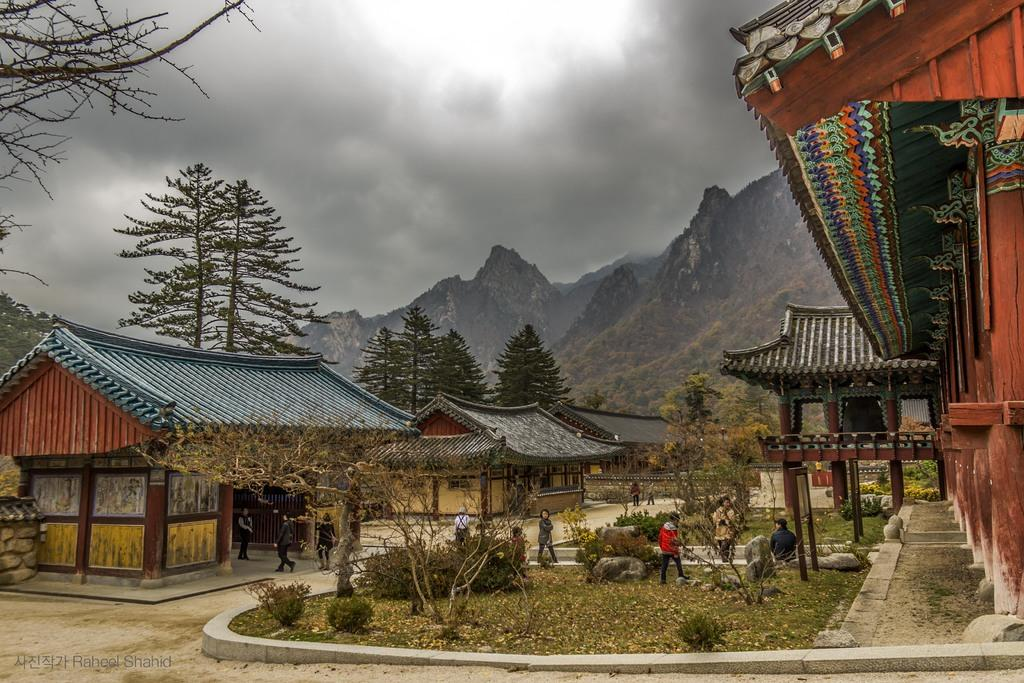What type of structures can be seen in the image? There are buildings in the image. What natural elements are present in the image? There are trees, shrubs, bushes, and rocks visible in the image. What is the condition of the sky in the image? The sky is visible in the background of the image, and there are clouds present. What can be seen in the distance in the image? There are hills visible in the background of the image. Are there any people visible in the image? Yes, there are persons on the ground in the image. What time of day is depicted in the image? The time of day cannot be determined from the image, as there are no specific indicators of time. Can you see a door on any of the buildings in the image? There is no door visible on any of the buildings in the image. Is there a tent set up in the image? There is no tent present in the image. 